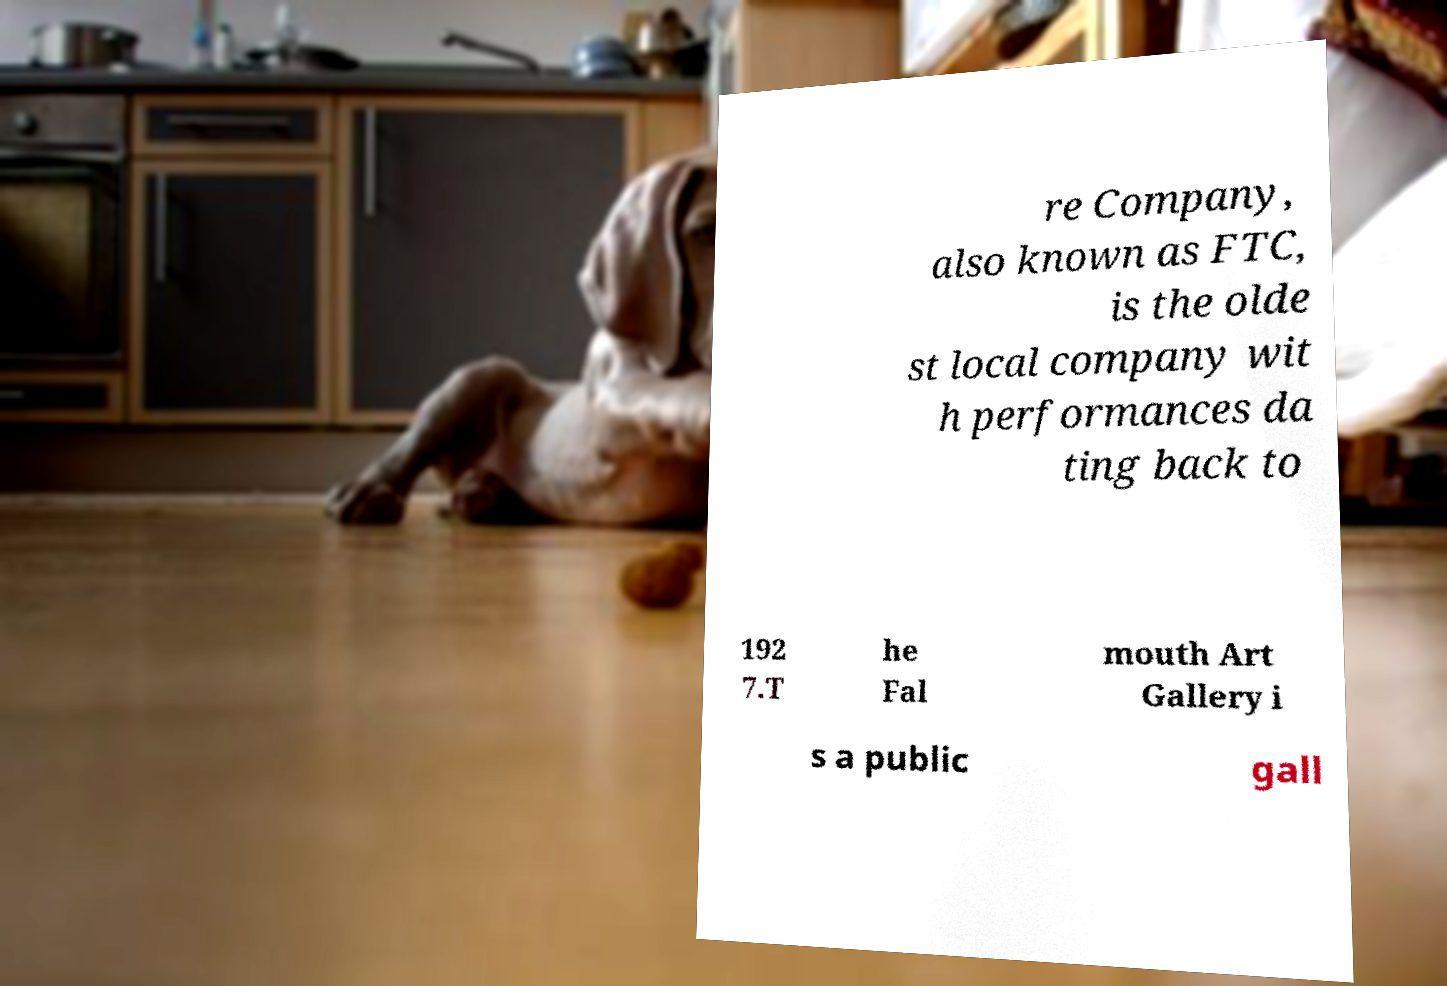Could you extract and type out the text from this image? re Company, also known as FTC, is the olde st local company wit h performances da ting back to 192 7.T he Fal mouth Art Gallery i s a public gall 